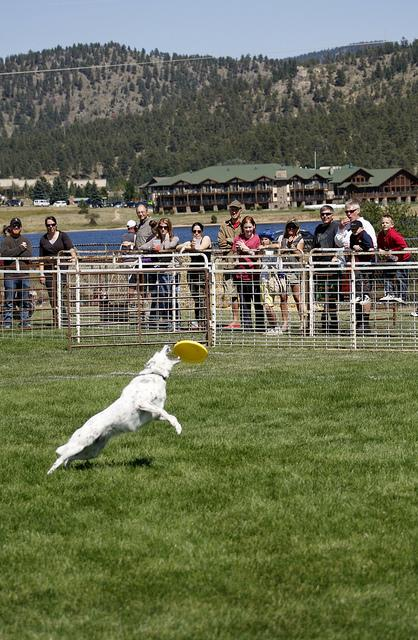Approximately how many people are watching the event? twenty 